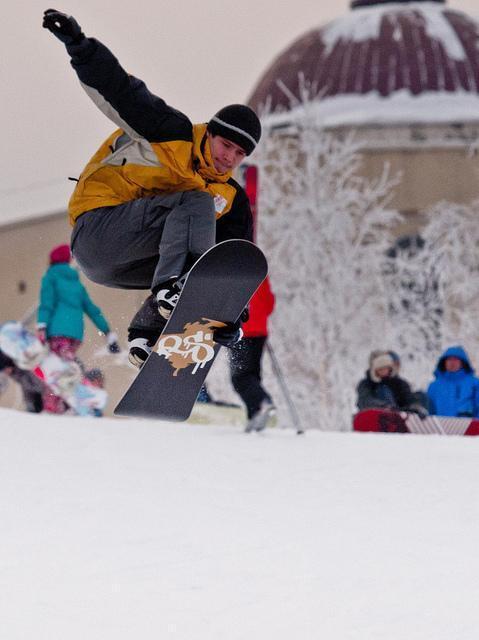How many people are in the photo?
Give a very brief answer. 5. How many ducks have orange hats?
Give a very brief answer. 0. 